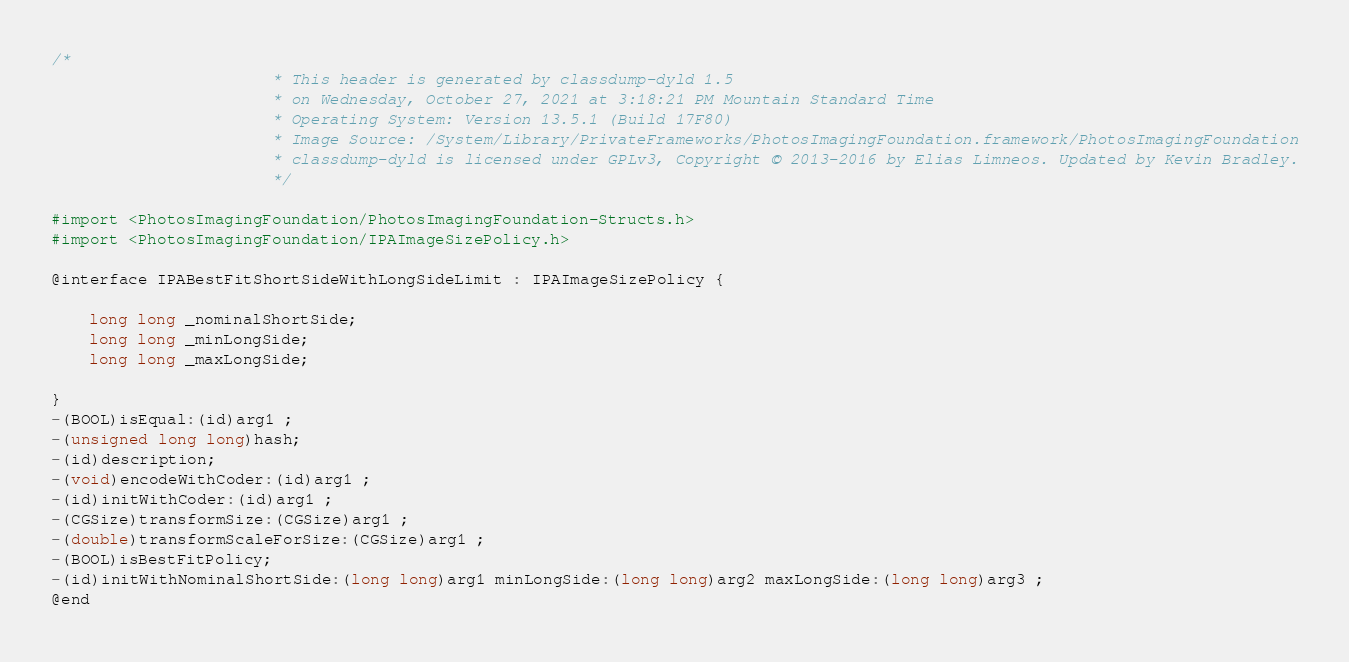Convert code to text. <code><loc_0><loc_0><loc_500><loc_500><_C_>/*
                       * This header is generated by classdump-dyld 1.5
                       * on Wednesday, October 27, 2021 at 3:18:21 PM Mountain Standard Time
                       * Operating System: Version 13.5.1 (Build 17F80)
                       * Image Source: /System/Library/PrivateFrameworks/PhotosImagingFoundation.framework/PhotosImagingFoundation
                       * classdump-dyld is licensed under GPLv3, Copyright © 2013-2016 by Elias Limneos. Updated by Kevin Bradley.
                       */

#import <PhotosImagingFoundation/PhotosImagingFoundation-Structs.h>
#import <PhotosImagingFoundation/IPAImageSizePolicy.h>

@interface IPABestFitShortSideWithLongSideLimit : IPAImageSizePolicy {

	long long _nominalShortSide;
	long long _minLongSide;
	long long _maxLongSide;

}
-(BOOL)isEqual:(id)arg1 ;
-(unsigned long long)hash;
-(id)description;
-(void)encodeWithCoder:(id)arg1 ;
-(id)initWithCoder:(id)arg1 ;
-(CGSize)transformSize:(CGSize)arg1 ;
-(double)transformScaleForSize:(CGSize)arg1 ;
-(BOOL)isBestFitPolicy;
-(id)initWithNominalShortSide:(long long)arg1 minLongSide:(long long)arg2 maxLongSide:(long long)arg3 ;
@end

</code> 